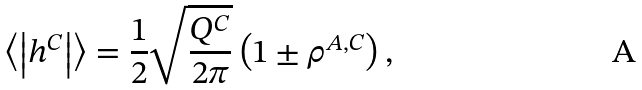Convert formula to latex. <formula><loc_0><loc_0><loc_500><loc_500>\left \langle \left | h ^ { C } \right | \right \rangle = \frac { 1 } { 2 } \sqrt { \frac { Q ^ { C } } { 2 \pi } } \left ( 1 \pm \rho ^ { A , C } \right ) ,</formula> 